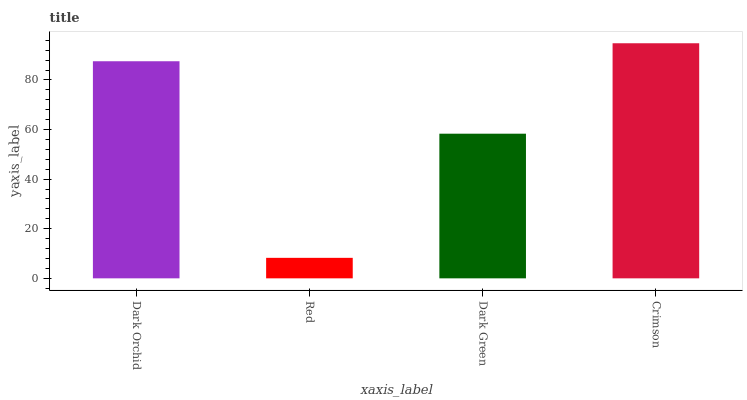Is Red the minimum?
Answer yes or no. Yes. Is Crimson the maximum?
Answer yes or no. Yes. Is Dark Green the minimum?
Answer yes or no. No. Is Dark Green the maximum?
Answer yes or no. No. Is Dark Green greater than Red?
Answer yes or no. Yes. Is Red less than Dark Green?
Answer yes or no. Yes. Is Red greater than Dark Green?
Answer yes or no. No. Is Dark Green less than Red?
Answer yes or no. No. Is Dark Orchid the high median?
Answer yes or no. Yes. Is Dark Green the low median?
Answer yes or no. Yes. Is Dark Green the high median?
Answer yes or no. No. Is Red the low median?
Answer yes or no. No. 